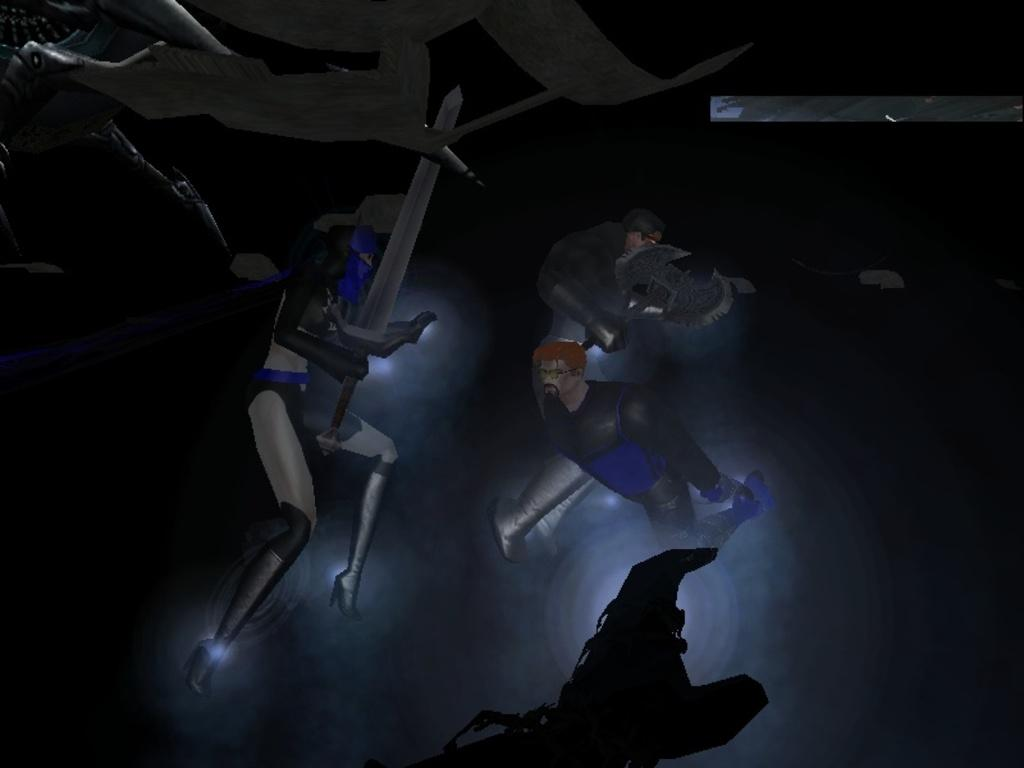What type of picture is in the image? The image contains an animated picture. What can be seen happening in the animated picture? There are people in the animated picture. What are the people in the animated picture doing? The people are holding weapons in their hands. What type of industry can be seen in the background of the animated picture? There is no industry visible in the background of the animated picture; it only shows people holding weapons. 